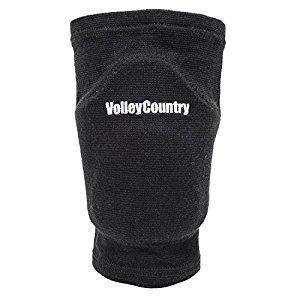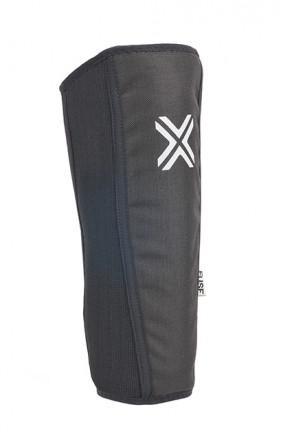The first image is the image on the left, the second image is the image on the right. Evaluate the accuracy of this statement regarding the images: "One or more of the knee pads has an """"X"""" logo". Is it true? Answer yes or no. Yes. The first image is the image on the left, the second image is the image on the right. Analyze the images presented: Is the assertion "At least one padded gear has the letter X on it." valid? Answer yes or no. Yes. 